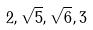<formula> <loc_0><loc_0><loc_500><loc_500>2 , \sqrt { 5 } , \sqrt { 6 } , 3</formula> 